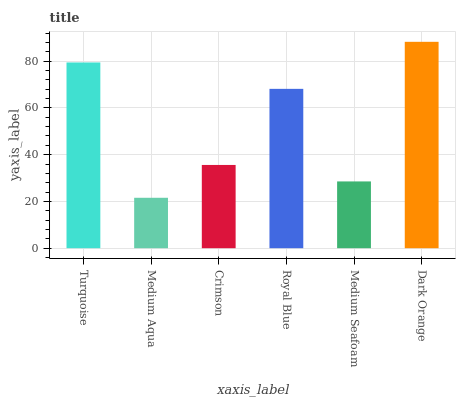Is Medium Aqua the minimum?
Answer yes or no. Yes. Is Dark Orange the maximum?
Answer yes or no. Yes. Is Crimson the minimum?
Answer yes or no. No. Is Crimson the maximum?
Answer yes or no. No. Is Crimson greater than Medium Aqua?
Answer yes or no. Yes. Is Medium Aqua less than Crimson?
Answer yes or no. Yes. Is Medium Aqua greater than Crimson?
Answer yes or no. No. Is Crimson less than Medium Aqua?
Answer yes or no. No. Is Royal Blue the high median?
Answer yes or no. Yes. Is Crimson the low median?
Answer yes or no. Yes. Is Dark Orange the high median?
Answer yes or no. No. Is Dark Orange the low median?
Answer yes or no. No. 